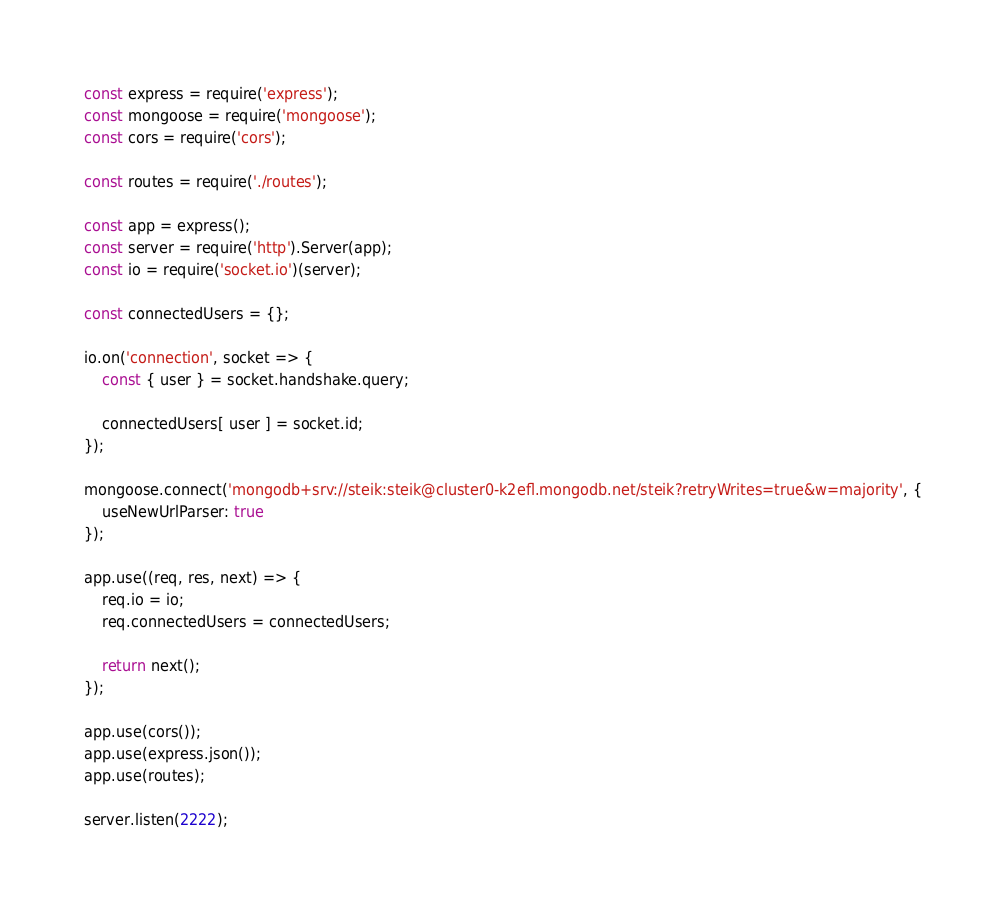<code> <loc_0><loc_0><loc_500><loc_500><_JavaScript_>const express = require('express');
const mongoose = require('mongoose');
const cors = require('cors');

const routes = require('./routes');

const app = express();
const server = require('http').Server(app);
const io = require('socket.io')(server);

const connectedUsers = {};

io.on('connection', socket => {
    const { user } = socket.handshake.query;

    connectedUsers[ user ] = socket.id;
});

mongoose.connect('mongodb+srv://steik:steik@cluster0-k2efl.mongodb.net/steik?retryWrites=true&w=majority', {
    useNewUrlParser: true
});

app.use((req, res, next) => {
    req.io = io;
    req.connectedUsers = connectedUsers;

    return next();
});

app.use(cors());
app.use(express.json());
app.use(routes);

server.listen(2222);
</code> 